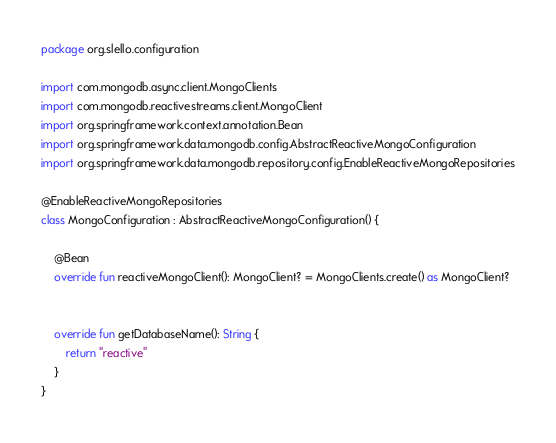Convert code to text. <code><loc_0><loc_0><loc_500><loc_500><_Kotlin_>package org.slello.configuration

import com.mongodb.async.client.MongoClients
import com.mongodb.reactivestreams.client.MongoClient
import org.springframework.context.annotation.Bean
import org.springframework.data.mongodb.config.AbstractReactiveMongoConfiguration
import org.springframework.data.mongodb.repository.config.EnableReactiveMongoRepositories

@EnableReactiveMongoRepositories
class MongoConfiguration : AbstractReactiveMongoConfiguration() {

    @Bean
    override fun reactiveMongoClient(): MongoClient? = MongoClients.create() as MongoClient?


    override fun getDatabaseName(): String {
        return "reactive"
    }
}</code> 